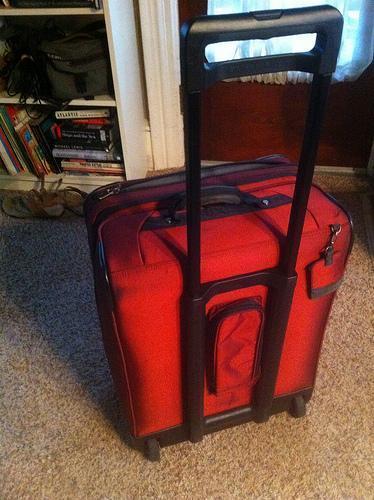How many pieces of luggage are there?
Give a very brief answer. 1. How many pairs of shoes are there?
Give a very brief answer. 1. 